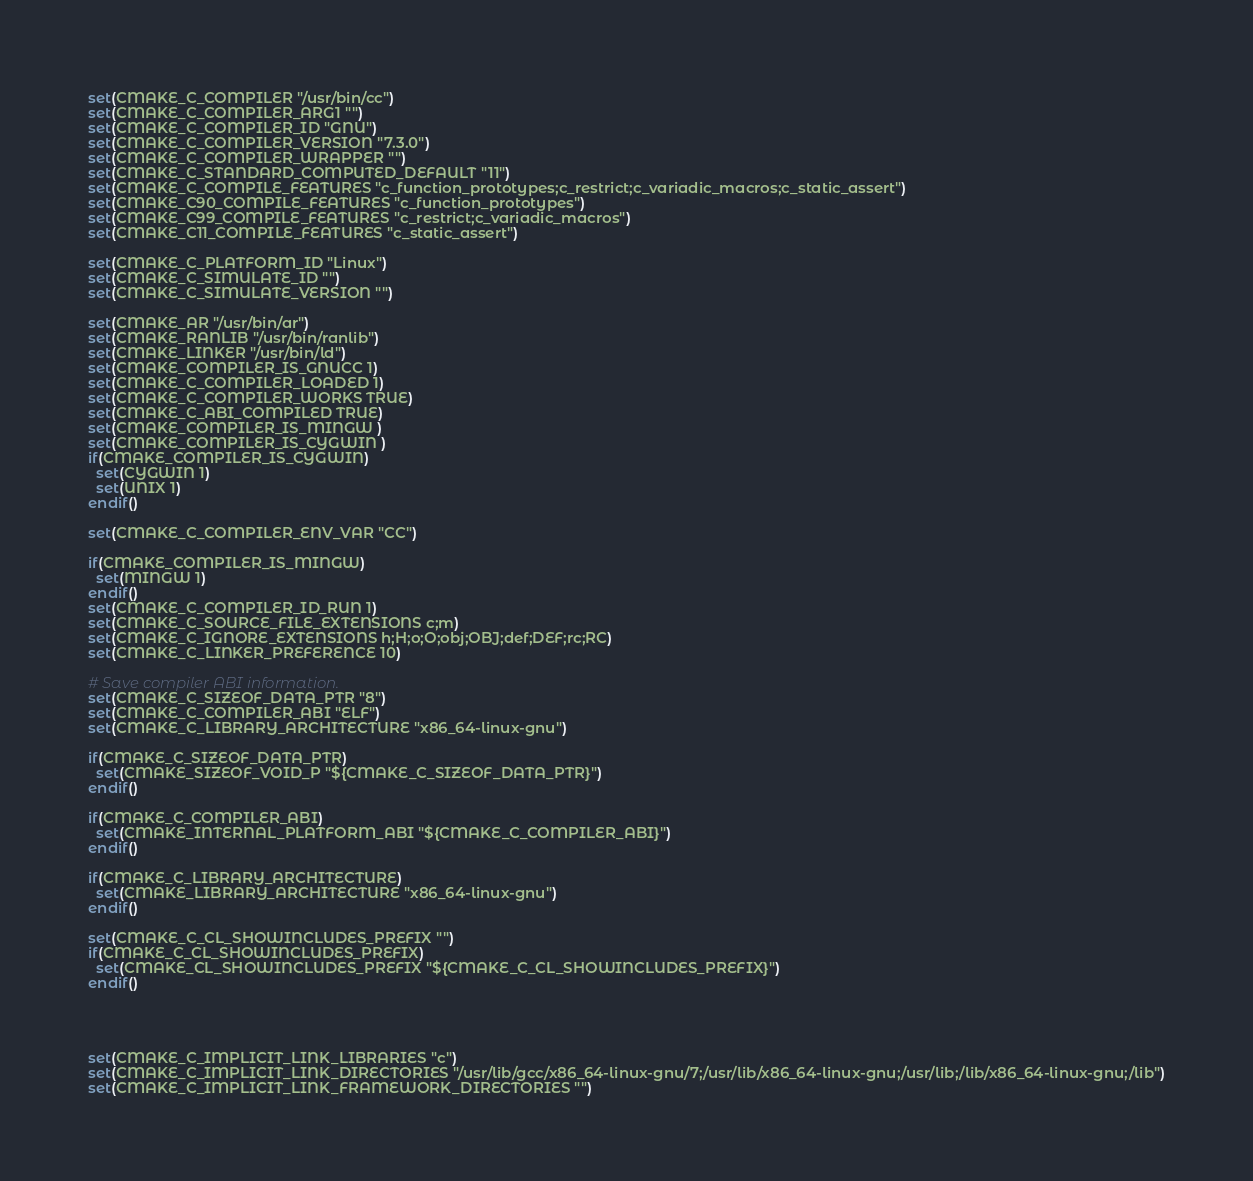<code> <loc_0><loc_0><loc_500><loc_500><_CMake_>set(CMAKE_C_COMPILER "/usr/bin/cc")
set(CMAKE_C_COMPILER_ARG1 "")
set(CMAKE_C_COMPILER_ID "GNU")
set(CMAKE_C_COMPILER_VERSION "7.3.0")
set(CMAKE_C_COMPILER_WRAPPER "")
set(CMAKE_C_STANDARD_COMPUTED_DEFAULT "11")
set(CMAKE_C_COMPILE_FEATURES "c_function_prototypes;c_restrict;c_variadic_macros;c_static_assert")
set(CMAKE_C90_COMPILE_FEATURES "c_function_prototypes")
set(CMAKE_C99_COMPILE_FEATURES "c_restrict;c_variadic_macros")
set(CMAKE_C11_COMPILE_FEATURES "c_static_assert")

set(CMAKE_C_PLATFORM_ID "Linux")
set(CMAKE_C_SIMULATE_ID "")
set(CMAKE_C_SIMULATE_VERSION "")

set(CMAKE_AR "/usr/bin/ar")
set(CMAKE_RANLIB "/usr/bin/ranlib")
set(CMAKE_LINKER "/usr/bin/ld")
set(CMAKE_COMPILER_IS_GNUCC 1)
set(CMAKE_C_COMPILER_LOADED 1)
set(CMAKE_C_COMPILER_WORKS TRUE)
set(CMAKE_C_ABI_COMPILED TRUE)
set(CMAKE_COMPILER_IS_MINGW )
set(CMAKE_COMPILER_IS_CYGWIN )
if(CMAKE_COMPILER_IS_CYGWIN)
  set(CYGWIN 1)
  set(UNIX 1)
endif()

set(CMAKE_C_COMPILER_ENV_VAR "CC")

if(CMAKE_COMPILER_IS_MINGW)
  set(MINGW 1)
endif()
set(CMAKE_C_COMPILER_ID_RUN 1)
set(CMAKE_C_SOURCE_FILE_EXTENSIONS c;m)
set(CMAKE_C_IGNORE_EXTENSIONS h;H;o;O;obj;OBJ;def;DEF;rc;RC)
set(CMAKE_C_LINKER_PREFERENCE 10)

# Save compiler ABI information.
set(CMAKE_C_SIZEOF_DATA_PTR "8")
set(CMAKE_C_COMPILER_ABI "ELF")
set(CMAKE_C_LIBRARY_ARCHITECTURE "x86_64-linux-gnu")

if(CMAKE_C_SIZEOF_DATA_PTR)
  set(CMAKE_SIZEOF_VOID_P "${CMAKE_C_SIZEOF_DATA_PTR}")
endif()

if(CMAKE_C_COMPILER_ABI)
  set(CMAKE_INTERNAL_PLATFORM_ABI "${CMAKE_C_COMPILER_ABI}")
endif()

if(CMAKE_C_LIBRARY_ARCHITECTURE)
  set(CMAKE_LIBRARY_ARCHITECTURE "x86_64-linux-gnu")
endif()

set(CMAKE_C_CL_SHOWINCLUDES_PREFIX "")
if(CMAKE_C_CL_SHOWINCLUDES_PREFIX)
  set(CMAKE_CL_SHOWINCLUDES_PREFIX "${CMAKE_C_CL_SHOWINCLUDES_PREFIX}")
endif()




set(CMAKE_C_IMPLICIT_LINK_LIBRARIES "c")
set(CMAKE_C_IMPLICIT_LINK_DIRECTORIES "/usr/lib/gcc/x86_64-linux-gnu/7;/usr/lib/x86_64-linux-gnu;/usr/lib;/lib/x86_64-linux-gnu;/lib")
set(CMAKE_C_IMPLICIT_LINK_FRAMEWORK_DIRECTORIES "")
</code> 